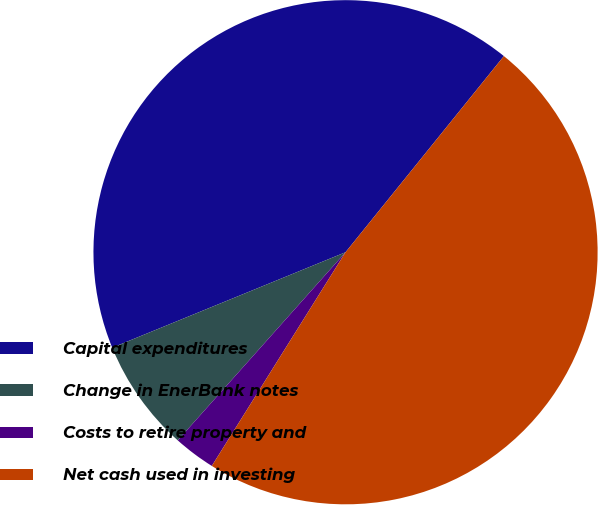Convert chart to OTSL. <chart><loc_0><loc_0><loc_500><loc_500><pie_chart><fcel>Capital expenditures<fcel>Change in EnerBank notes<fcel>Costs to retire property and<fcel>Net cash used in investing<nl><fcel>41.99%<fcel>7.23%<fcel>2.69%<fcel>48.09%<nl></chart> 